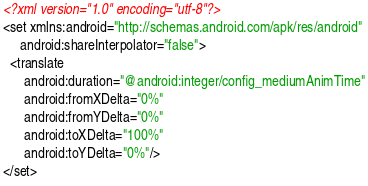<code> <loc_0><loc_0><loc_500><loc_500><_XML_><?xml version="1.0" encoding="utf-8"?>
<set xmlns:android="http://schemas.android.com/apk/res/android"
     android:shareInterpolator="false">
  <translate
      android:duration="@android:integer/config_mediumAnimTime"
      android:fromXDelta="0%"
      android:fromYDelta="0%"
      android:toXDelta="100%"
      android:toYDelta="0%"/>
</set></code> 